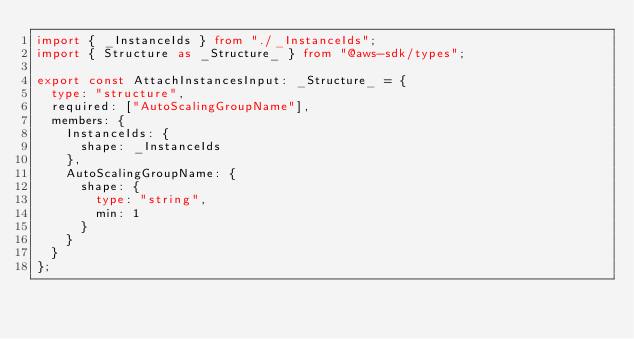<code> <loc_0><loc_0><loc_500><loc_500><_TypeScript_>import { _InstanceIds } from "./_InstanceIds";
import { Structure as _Structure_ } from "@aws-sdk/types";

export const AttachInstancesInput: _Structure_ = {
  type: "structure",
  required: ["AutoScalingGroupName"],
  members: {
    InstanceIds: {
      shape: _InstanceIds
    },
    AutoScalingGroupName: {
      shape: {
        type: "string",
        min: 1
      }
    }
  }
};
</code> 